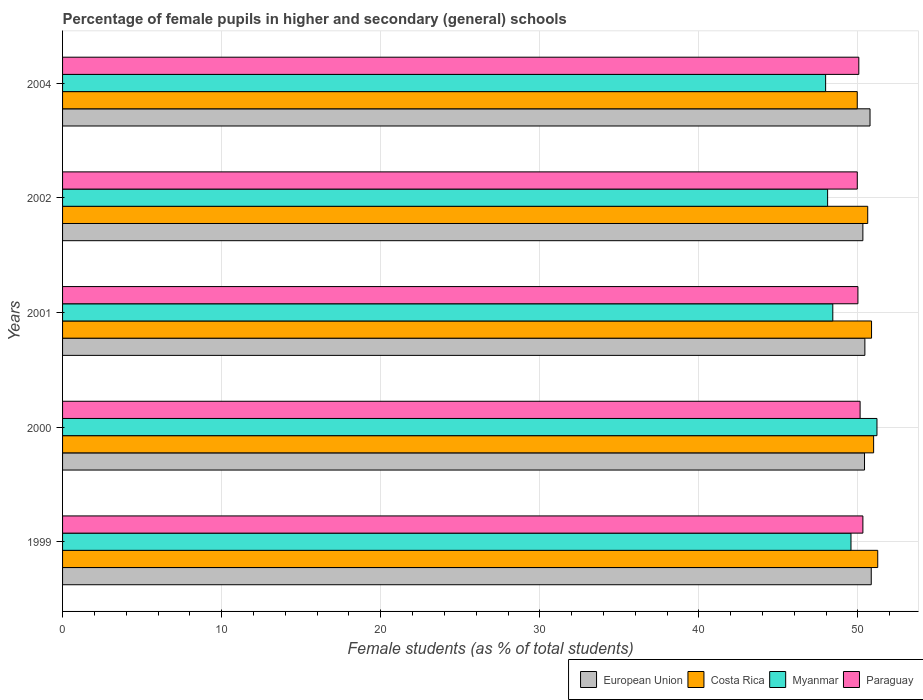How many different coloured bars are there?
Keep it short and to the point. 4. Are the number of bars on each tick of the Y-axis equal?
Offer a terse response. Yes. How many bars are there on the 2nd tick from the top?
Offer a very short reply. 4. How many bars are there on the 5th tick from the bottom?
Provide a succinct answer. 4. In how many cases, is the number of bars for a given year not equal to the number of legend labels?
Offer a very short reply. 0. What is the percentage of female pupils in higher and secondary schools in Myanmar in 1999?
Your answer should be very brief. 49.56. Across all years, what is the maximum percentage of female pupils in higher and secondary schools in Myanmar?
Make the answer very short. 51.19. Across all years, what is the minimum percentage of female pupils in higher and secondary schools in Paraguay?
Offer a terse response. 49.96. In which year was the percentage of female pupils in higher and secondary schools in European Union maximum?
Give a very brief answer. 1999. What is the total percentage of female pupils in higher and secondary schools in Costa Rica in the graph?
Give a very brief answer. 253.64. What is the difference between the percentage of female pupils in higher and secondary schools in European Union in 1999 and that in 2002?
Ensure brevity in your answer.  0.53. What is the difference between the percentage of female pupils in higher and secondary schools in Paraguay in 2004 and the percentage of female pupils in higher and secondary schools in European Union in 2001?
Ensure brevity in your answer.  -0.38. What is the average percentage of female pupils in higher and secondary schools in Myanmar per year?
Your response must be concise. 49.05. In the year 2004, what is the difference between the percentage of female pupils in higher and secondary schools in Myanmar and percentage of female pupils in higher and secondary schools in Paraguay?
Provide a short and direct response. -2.09. What is the ratio of the percentage of female pupils in higher and secondary schools in Myanmar in 1999 to that in 2002?
Your answer should be very brief. 1.03. Is the difference between the percentage of female pupils in higher and secondary schools in Myanmar in 1999 and 2004 greater than the difference between the percentage of female pupils in higher and secondary schools in Paraguay in 1999 and 2004?
Your response must be concise. Yes. What is the difference between the highest and the second highest percentage of female pupils in higher and secondary schools in European Union?
Give a very brief answer. 0.08. What is the difference between the highest and the lowest percentage of female pupils in higher and secondary schools in European Union?
Offer a very short reply. 0.53. In how many years, is the percentage of female pupils in higher and secondary schools in European Union greater than the average percentage of female pupils in higher and secondary schools in European Union taken over all years?
Make the answer very short. 2. Is the sum of the percentage of female pupils in higher and secondary schools in Paraguay in 1999 and 2001 greater than the maximum percentage of female pupils in higher and secondary schools in Myanmar across all years?
Offer a very short reply. Yes. Is it the case that in every year, the sum of the percentage of female pupils in higher and secondary schools in Paraguay and percentage of female pupils in higher and secondary schools in European Union is greater than the sum of percentage of female pupils in higher and secondary schools in Myanmar and percentage of female pupils in higher and secondary schools in Costa Rica?
Provide a short and direct response. No. What does the 2nd bar from the bottom in 2004 represents?
Give a very brief answer. Costa Rica. Is it the case that in every year, the sum of the percentage of female pupils in higher and secondary schools in Costa Rica and percentage of female pupils in higher and secondary schools in Myanmar is greater than the percentage of female pupils in higher and secondary schools in Paraguay?
Give a very brief answer. Yes. Are all the bars in the graph horizontal?
Your answer should be very brief. Yes. Does the graph contain grids?
Provide a short and direct response. Yes. Where does the legend appear in the graph?
Provide a succinct answer. Bottom right. How many legend labels are there?
Your answer should be compact. 4. How are the legend labels stacked?
Keep it short and to the point. Horizontal. What is the title of the graph?
Make the answer very short. Percentage of female pupils in higher and secondary (general) schools. What is the label or title of the X-axis?
Your answer should be compact. Female students (as % of total students). What is the Female students (as % of total students) of European Union in 1999?
Provide a short and direct response. 50.83. What is the Female students (as % of total students) of Costa Rica in 1999?
Provide a succinct answer. 51.24. What is the Female students (as % of total students) in Myanmar in 1999?
Your answer should be very brief. 49.56. What is the Female students (as % of total students) in Paraguay in 1999?
Provide a short and direct response. 50.31. What is the Female students (as % of total students) of European Union in 2000?
Your response must be concise. 50.41. What is the Female students (as % of total students) in Costa Rica in 2000?
Provide a short and direct response. 50.98. What is the Female students (as % of total students) of Myanmar in 2000?
Ensure brevity in your answer.  51.19. What is the Female students (as % of total students) in Paraguay in 2000?
Ensure brevity in your answer.  50.13. What is the Female students (as % of total students) of European Union in 2001?
Your answer should be compact. 50.43. What is the Female students (as % of total students) in Costa Rica in 2001?
Your response must be concise. 50.85. What is the Female students (as % of total students) in Myanmar in 2001?
Provide a succinct answer. 48.42. What is the Female students (as % of total students) in Paraguay in 2001?
Offer a very short reply. 50. What is the Female students (as % of total students) of European Union in 2002?
Give a very brief answer. 50.31. What is the Female students (as % of total students) of Costa Rica in 2002?
Provide a succinct answer. 50.61. What is the Female students (as % of total students) of Myanmar in 2002?
Offer a terse response. 48.09. What is the Female students (as % of total students) in Paraguay in 2002?
Provide a short and direct response. 49.96. What is the Female students (as % of total students) in European Union in 2004?
Your answer should be very brief. 50.76. What is the Female students (as % of total students) in Costa Rica in 2004?
Provide a succinct answer. 49.95. What is the Female students (as % of total students) in Myanmar in 2004?
Provide a succinct answer. 47.97. What is the Female students (as % of total students) in Paraguay in 2004?
Offer a terse response. 50.05. Across all years, what is the maximum Female students (as % of total students) in European Union?
Your response must be concise. 50.83. Across all years, what is the maximum Female students (as % of total students) of Costa Rica?
Offer a very short reply. 51.24. Across all years, what is the maximum Female students (as % of total students) of Myanmar?
Keep it short and to the point. 51.19. Across all years, what is the maximum Female students (as % of total students) of Paraguay?
Keep it short and to the point. 50.31. Across all years, what is the minimum Female students (as % of total students) in European Union?
Ensure brevity in your answer.  50.31. Across all years, what is the minimum Female students (as % of total students) of Costa Rica?
Provide a succinct answer. 49.95. Across all years, what is the minimum Female students (as % of total students) of Myanmar?
Give a very brief answer. 47.97. Across all years, what is the minimum Female students (as % of total students) of Paraguay?
Offer a very short reply. 49.96. What is the total Female students (as % of total students) of European Union in the graph?
Ensure brevity in your answer.  252.74. What is the total Female students (as % of total students) in Costa Rica in the graph?
Your response must be concise. 253.64. What is the total Female students (as % of total students) of Myanmar in the graph?
Make the answer very short. 245.23. What is the total Female students (as % of total students) in Paraguay in the graph?
Offer a very short reply. 250.44. What is the difference between the Female students (as % of total students) of European Union in 1999 and that in 2000?
Provide a succinct answer. 0.42. What is the difference between the Female students (as % of total students) in Costa Rica in 1999 and that in 2000?
Your response must be concise. 0.26. What is the difference between the Female students (as % of total students) in Myanmar in 1999 and that in 2000?
Give a very brief answer. -1.63. What is the difference between the Female students (as % of total students) of Paraguay in 1999 and that in 2000?
Your response must be concise. 0.17. What is the difference between the Female students (as % of total students) in European Union in 1999 and that in 2001?
Ensure brevity in your answer.  0.4. What is the difference between the Female students (as % of total students) in Costa Rica in 1999 and that in 2001?
Provide a short and direct response. 0.39. What is the difference between the Female students (as % of total students) of Myanmar in 1999 and that in 2001?
Keep it short and to the point. 1.14. What is the difference between the Female students (as % of total students) of Paraguay in 1999 and that in 2001?
Provide a succinct answer. 0.31. What is the difference between the Female students (as % of total students) in European Union in 1999 and that in 2002?
Make the answer very short. 0.53. What is the difference between the Female students (as % of total students) of Costa Rica in 1999 and that in 2002?
Ensure brevity in your answer.  0.63. What is the difference between the Female students (as % of total students) in Myanmar in 1999 and that in 2002?
Offer a terse response. 1.47. What is the difference between the Female students (as % of total students) of Paraguay in 1999 and that in 2002?
Your answer should be compact. 0.35. What is the difference between the Female students (as % of total students) in European Union in 1999 and that in 2004?
Keep it short and to the point. 0.08. What is the difference between the Female students (as % of total students) of Costa Rica in 1999 and that in 2004?
Offer a very short reply. 1.29. What is the difference between the Female students (as % of total students) in Myanmar in 1999 and that in 2004?
Your answer should be very brief. 1.59. What is the difference between the Female students (as % of total students) in Paraguay in 1999 and that in 2004?
Offer a very short reply. 0.26. What is the difference between the Female students (as % of total students) of European Union in 2000 and that in 2001?
Keep it short and to the point. -0.02. What is the difference between the Female students (as % of total students) of Costa Rica in 2000 and that in 2001?
Keep it short and to the point. 0.13. What is the difference between the Female students (as % of total students) in Myanmar in 2000 and that in 2001?
Offer a terse response. 2.78. What is the difference between the Female students (as % of total students) in Paraguay in 2000 and that in 2001?
Keep it short and to the point. 0.14. What is the difference between the Female students (as % of total students) in European Union in 2000 and that in 2002?
Ensure brevity in your answer.  0.1. What is the difference between the Female students (as % of total students) of Costa Rica in 2000 and that in 2002?
Offer a terse response. 0.37. What is the difference between the Female students (as % of total students) of Myanmar in 2000 and that in 2002?
Your answer should be compact. 3.1. What is the difference between the Female students (as % of total students) of Paraguay in 2000 and that in 2002?
Provide a succinct answer. 0.18. What is the difference between the Female students (as % of total students) of European Union in 2000 and that in 2004?
Make the answer very short. -0.35. What is the difference between the Female students (as % of total students) of Costa Rica in 2000 and that in 2004?
Give a very brief answer. 1.03. What is the difference between the Female students (as % of total students) of Myanmar in 2000 and that in 2004?
Your answer should be compact. 3.23. What is the difference between the Female students (as % of total students) of Paraguay in 2000 and that in 2004?
Keep it short and to the point. 0.08. What is the difference between the Female students (as % of total students) in European Union in 2001 and that in 2002?
Ensure brevity in your answer.  0.13. What is the difference between the Female students (as % of total students) in Costa Rica in 2001 and that in 2002?
Offer a very short reply. 0.24. What is the difference between the Female students (as % of total students) of Myanmar in 2001 and that in 2002?
Give a very brief answer. 0.33. What is the difference between the Female students (as % of total students) in Paraguay in 2001 and that in 2002?
Keep it short and to the point. 0.04. What is the difference between the Female students (as % of total students) in European Union in 2001 and that in 2004?
Your answer should be very brief. -0.32. What is the difference between the Female students (as % of total students) in Costa Rica in 2001 and that in 2004?
Offer a terse response. 0.9. What is the difference between the Female students (as % of total students) in Myanmar in 2001 and that in 2004?
Your response must be concise. 0.45. What is the difference between the Female students (as % of total students) of Paraguay in 2001 and that in 2004?
Offer a terse response. -0.06. What is the difference between the Female students (as % of total students) in European Union in 2002 and that in 2004?
Provide a succinct answer. -0.45. What is the difference between the Female students (as % of total students) of Costa Rica in 2002 and that in 2004?
Keep it short and to the point. 0.66. What is the difference between the Female students (as % of total students) in Myanmar in 2002 and that in 2004?
Your response must be concise. 0.12. What is the difference between the Female students (as % of total students) of Paraguay in 2002 and that in 2004?
Give a very brief answer. -0.1. What is the difference between the Female students (as % of total students) of European Union in 1999 and the Female students (as % of total students) of Costa Rica in 2000?
Provide a succinct answer. -0.15. What is the difference between the Female students (as % of total students) in European Union in 1999 and the Female students (as % of total students) in Myanmar in 2000?
Your answer should be very brief. -0.36. What is the difference between the Female students (as % of total students) of European Union in 1999 and the Female students (as % of total students) of Paraguay in 2000?
Ensure brevity in your answer.  0.7. What is the difference between the Female students (as % of total students) in Costa Rica in 1999 and the Female students (as % of total students) in Myanmar in 2000?
Offer a very short reply. 0.05. What is the difference between the Female students (as % of total students) of Costa Rica in 1999 and the Female students (as % of total students) of Paraguay in 2000?
Offer a very short reply. 1.11. What is the difference between the Female students (as % of total students) in Myanmar in 1999 and the Female students (as % of total students) in Paraguay in 2000?
Ensure brevity in your answer.  -0.57. What is the difference between the Female students (as % of total students) in European Union in 1999 and the Female students (as % of total students) in Costa Rica in 2001?
Your answer should be very brief. -0.02. What is the difference between the Female students (as % of total students) of European Union in 1999 and the Female students (as % of total students) of Myanmar in 2001?
Make the answer very short. 2.42. What is the difference between the Female students (as % of total students) of European Union in 1999 and the Female students (as % of total students) of Paraguay in 2001?
Give a very brief answer. 0.84. What is the difference between the Female students (as % of total students) in Costa Rica in 1999 and the Female students (as % of total students) in Myanmar in 2001?
Offer a very short reply. 2.82. What is the difference between the Female students (as % of total students) in Costa Rica in 1999 and the Female students (as % of total students) in Paraguay in 2001?
Your response must be concise. 1.25. What is the difference between the Female students (as % of total students) of Myanmar in 1999 and the Female students (as % of total students) of Paraguay in 2001?
Your response must be concise. -0.44. What is the difference between the Female students (as % of total students) of European Union in 1999 and the Female students (as % of total students) of Costa Rica in 2002?
Your answer should be compact. 0.22. What is the difference between the Female students (as % of total students) in European Union in 1999 and the Female students (as % of total students) in Myanmar in 2002?
Provide a succinct answer. 2.74. What is the difference between the Female students (as % of total students) of European Union in 1999 and the Female students (as % of total students) of Paraguay in 2002?
Your answer should be very brief. 0.88. What is the difference between the Female students (as % of total students) of Costa Rica in 1999 and the Female students (as % of total students) of Myanmar in 2002?
Your answer should be very brief. 3.15. What is the difference between the Female students (as % of total students) in Costa Rica in 1999 and the Female students (as % of total students) in Paraguay in 2002?
Give a very brief answer. 1.29. What is the difference between the Female students (as % of total students) of Myanmar in 1999 and the Female students (as % of total students) of Paraguay in 2002?
Make the answer very short. -0.4. What is the difference between the Female students (as % of total students) in European Union in 1999 and the Female students (as % of total students) in Costa Rica in 2004?
Offer a very short reply. 0.88. What is the difference between the Female students (as % of total students) in European Union in 1999 and the Female students (as % of total students) in Myanmar in 2004?
Provide a short and direct response. 2.87. What is the difference between the Female students (as % of total students) in European Union in 1999 and the Female students (as % of total students) in Paraguay in 2004?
Provide a short and direct response. 0.78. What is the difference between the Female students (as % of total students) of Costa Rica in 1999 and the Female students (as % of total students) of Myanmar in 2004?
Make the answer very short. 3.28. What is the difference between the Female students (as % of total students) of Costa Rica in 1999 and the Female students (as % of total students) of Paraguay in 2004?
Provide a succinct answer. 1.19. What is the difference between the Female students (as % of total students) in Myanmar in 1999 and the Female students (as % of total students) in Paraguay in 2004?
Make the answer very short. -0.49. What is the difference between the Female students (as % of total students) in European Union in 2000 and the Female students (as % of total students) in Costa Rica in 2001?
Provide a succinct answer. -0.44. What is the difference between the Female students (as % of total students) of European Union in 2000 and the Female students (as % of total students) of Myanmar in 2001?
Your response must be concise. 1.99. What is the difference between the Female students (as % of total students) in European Union in 2000 and the Female students (as % of total students) in Paraguay in 2001?
Keep it short and to the point. 0.41. What is the difference between the Female students (as % of total students) of Costa Rica in 2000 and the Female students (as % of total students) of Myanmar in 2001?
Your answer should be very brief. 2.57. What is the difference between the Female students (as % of total students) of Costa Rica in 2000 and the Female students (as % of total students) of Paraguay in 2001?
Your answer should be compact. 0.99. What is the difference between the Female students (as % of total students) in Myanmar in 2000 and the Female students (as % of total students) in Paraguay in 2001?
Ensure brevity in your answer.  1.2. What is the difference between the Female students (as % of total students) of European Union in 2000 and the Female students (as % of total students) of Costa Rica in 2002?
Ensure brevity in your answer.  -0.2. What is the difference between the Female students (as % of total students) of European Union in 2000 and the Female students (as % of total students) of Myanmar in 2002?
Provide a short and direct response. 2.32. What is the difference between the Female students (as % of total students) in European Union in 2000 and the Female students (as % of total students) in Paraguay in 2002?
Your response must be concise. 0.45. What is the difference between the Female students (as % of total students) in Costa Rica in 2000 and the Female students (as % of total students) in Myanmar in 2002?
Provide a succinct answer. 2.89. What is the difference between the Female students (as % of total students) in Costa Rica in 2000 and the Female students (as % of total students) in Paraguay in 2002?
Provide a succinct answer. 1.03. What is the difference between the Female students (as % of total students) in Myanmar in 2000 and the Female students (as % of total students) in Paraguay in 2002?
Offer a terse response. 1.24. What is the difference between the Female students (as % of total students) in European Union in 2000 and the Female students (as % of total students) in Costa Rica in 2004?
Ensure brevity in your answer.  0.46. What is the difference between the Female students (as % of total students) of European Union in 2000 and the Female students (as % of total students) of Myanmar in 2004?
Your answer should be very brief. 2.44. What is the difference between the Female students (as % of total students) of European Union in 2000 and the Female students (as % of total students) of Paraguay in 2004?
Your answer should be compact. 0.36. What is the difference between the Female students (as % of total students) of Costa Rica in 2000 and the Female students (as % of total students) of Myanmar in 2004?
Ensure brevity in your answer.  3.02. What is the difference between the Female students (as % of total students) in Costa Rica in 2000 and the Female students (as % of total students) in Paraguay in 2004?
Provide a short and direct response. 0.93. What is the difference between the Female students (as % of total students) of Myanmar in 2000 and the Female students (as % of total students) of Paraguay in 2004?
Make the answer very short. 1.14. What is the difference between the Female students (as % of total students) in European Union in 2001 and the Female students (as % of total students) in Costa Rica in 2002?
Offer a very short reply. -0.18. What is the difference between the Female students (as % of total students) of European Union in 2001 and the Female students (as % of total students) of Myanmar in 2002?
Your answer should be compact. 2.34. What is the difference between the Female students (as % of total students) in European Union in 2001 and the Female students (as % of total students) in Paraguay in 2002?
Ensure brevity in your answer.  0.48. What is the difference between the Female students (as % of total students) in Costa Rica in 2001 and the Female students (as % of total students) in Myanmar in 2002?
Provide a succinct answer. 2.76. What is the difference between the Female students (as % of total students) of Costa Rica in 2001 and the Female students (as % of total students) of Paraguay in 2002?
Provide a short and direct response. 0.9. What is the difference between the Female students (as % of total students) of Myanmar in 2001 and the Female students (as % of total students) of Paraguay in 2002?
Your answer should be very brief. -1.54. What is the difference between the Female students (as % of total students) in European Union in 2001 and the Female students (as % of total students) in Costa Rica in 2004?
Give a very brief answer. 0.48. What is the difference between the Female students (as % of total students) of European Union in 2001 and the Female students (as % of total students) of Myanmar in 2004?
Your answer should be very brief. 2.47. What is the difference between the Female students (as % of total students) in European Union in 2001 and the Female students (as % of total students) in Paraguay in 2004?
Give a very brief answer. 0.38. What is the difference between the Female students (as % of total students) of Costa Rica in 2001 and the Female students (as % of total students) of Myanmar in 2004?
Provide a succinct answer. 2.89. What is the difference between the Female students (as % of total students) of Costa Rica in 2001 and the Female students (as % of total students) of Paraguay in 2004?
Offer a terse response. 0.8. What is the difference between the Female students (as % of total students) in Myanmar in 2001 and the Female students (as % of total students) in Paraguay in 2004?
Give a very brief answer. -1.64. What is the difference between the Female students (as % of total students) of European Union in 2002 and the Female students (as % of total students) of Costa Rica in 2004?
Your answer should be compact. 0.35. What is the difference between the Female students (as % of total students) of European Union in 2002 and the Female students (as % of total students) of Myanmar in 2004?
Offer a terse response. 2.34. What is the difference between the Female students (as % of total students) in European Union in 2002 and the Female students (as % of total students) in Paraguay in 2004?
Your response must be concise. 0.26. What is the difference between the Female students (as % of total students) of Costa Rica in 2002 and the Female students (as % of total students) of Myanmar in 2004?
Offer a very short reply. 2.65. What is the difference between the Female students (as % of total students) in Costa Rica in 2002 and the Female students (as % of total students) in Paraguay in 2004?
Make the answer very short. 0.56. What is the difference between the Female students (as % of total students) of Myanmar in 2002 and the Female students (as % of total students) of Paraguay in 2004?
Ensure brevity in your answer.  -1.96. What is the average Female students (as % of total students) in European Union per year?
Make the answer very short. 50.55. What is the average Female students (as % of total students) of Costa Rica per year?
Give a very brief answer. 50.73. What is the average Female students (as % of total students) of Myanmar per year?
Keep it short and to the point. 49.05. What is the average Female students (as % of total students) of Paraguay per year?
Provide a short and direct response. 50.09. In the year 1999, what is the difference between the Female students (as % of total students) of European Union and Female students (as % of total students) of Costa Rica?
Provide a short and direct response. -0.41. In the year 1999, what is the difference between the Female students (as % of total students) of European Union and Female students (as % of total students) of Myanmar?
Your answer should be compact. 1.27. In the year 1999, what is the difference between the Female students (as % of total students) in European Union and Female students (as % of total students) in Paraguay?
Your answer should be very brief. 0.53. In the year 1999, what is the difference between the Female students (as % of total students) of Costa Rica and Female students (as % of total students) of Myanmar?
Your response must be concise. 1.68. In the year 1999, what is the difference between the Female students (as % of total students) of Costa Rica and Female students (as % of total students) of Paraguay?
Your answer should be very brief. 0.93. In the year 1999, what is the difference between the Female students (as % of total students) of Myanmar and Female students (as % of total students) of Paraguay?
Ensure brevity in your answer.  -0.75. In the year 2000, what is the difference between the Female students (as % of total students) in European Union and Female students (as % of total students) in Costa Rica?
Keep it short and to the point. -0.57. In the year 2000, what is the difference between the Female students (as % of total students) in European Union and Female students (as % of total students) in Myanmar?
Provide a succinct answer. -0.78. In the year 2000, what is the difference between the Female students (as % of total students) of European Union and Female students (as % of total students) of Paraguay?
Provide a short and direct response. 0.28. In the year 2000, what is the difference between the Female students (as % of total students) of Costa Rica and Female students (as % of total students) of Myanmar?
Your answer should be compact. -0.21. In the year 2000, what is the difference between the Female students (as % of total students) in Costa Rica and Female students (as % of total students) in Paraguay?
Provide a succinct answer. 0.85. In the year 2000, what is the difference between the Female students (as % of total students) of Myanmar and Female students (as % of total students) of Paraguay?
Your answer should be very brief. 1.06. In the year 2001, what is the difference between the Female students (as % of total students) of European Union and Female students (as % of total students) of Costa Rica?
Provide a succinct answer. -0.42. In the year 2001, what is the difference between the Female students (as % of total students) of European Union and Female students (as % of total students) of Myanmar?
Your answer should be very brief. 2.02. In the year 2001, what is the difference between the Female students (as % of total students) of European Union and Female students (as % of total students) of Paraguay?
Your answer should be compact. 0.44. In the year 2001, what is the difference between the Female students (as % of total students) in Costa Rica and Female students (as % of total students) in Myanmar?
Provide a short and direct response. 2.44. In the year 2001, what is the difference between the Female students (as % of total students) in Costa Rica and Female students (as % of total students) in Paraguay?
Your response must be concise. 0.86. In the year 2001, what is the difference between the Female students (as % of total students) of Myanmar and Female students (as % of total students) of Paraguay?
Provide a succinct answer. -1.58. In the year 2002, what is the difference between the Female students (as % of total students) of European Union and Female students (as % of total students) of Costa Rica?
Ensure brevity in your answer.  -0.3. In the year 2002, what is the difference between the Female students (as % of total students) in European Union and Female students (as % of total students) in Myanmar?
Make the answer very short. 2.22. In the year 2002, what is the difference between the Female students (as % of total students) of European Union and Female students (as % of total students) of Paraguay?
Provide a short and direct response. 0.35. In the year 2002, what is the difference between the Female students (as % of total students) of Costa Rica and Female students (as % of total students) of Myanmar?
Your answer should be very brief. 2.52. In the year 2002, what is the difference between the Female students (as % of total students) of Costa Rica and Female students (as % of total students) of Paraguay?
Your answer should be compact. 0.66. In the year 2002, what is the difference between the Female students (as % of total students) of Myanmar and Female students (as % of total students) of Paraguay?
Keep it short and to the point. -1.87. In the year 2004, what is the difference between the Female students (as % of total students) of European Union and Female students (as % of total students) of Costa Rica?
Your response must be concise. 0.8. In the year 2004, what is the difference between the Female students (as % of total students) in European Union and Female students (as % of total students) in Myanmar?
Keep it short and to the point. 2.79. In the year 2004, what is the difference between the Female students (as % of total students) in European Union and Female students (as % of total students) in Paraguay?
Offer a terse response. 0.7. In the year 2004, what is the difference between the Female students (as % of total students) of Costa Rica and Female students (as % of total students) of Myanmar?
Give a very brief answer. 1.99. In the year 2004, what is the difference between the Female students (as % of total students) of Costa Rica and Female students (as % of total students) of Paraguay?
Your answer should be compact. -0.1. In the year 2004, what is the difference between the Female students (as % of total students) of Myanmar and Female students (as % of total students) of Paraguay?
Provide a short and direct response. -2.09. What is the ratio of the Female students (as % of total students) in European Union in 1999 to that in 2000?
Provide a short and direct response. 1.01. What is the ratio of the Female students (as % of total students) in Costa Rica in 1999 to that in 2000?
Make the answer very short. 1.01. What is the ratio of the Female students (as % of total students) in Myanmar in 1999 to that in 2000?
Give a very brief answer. 0.97. What is the ratio of the Female students (as % of total students) of European Union in 1999 to that in 2001?
Make the answer very short. 1.01. What is the ratio of the Female students (as % of total students) of Costa Rica in 1999 to that in 2001?
Make the answer very short. 1.01. What is the ratio of the Female students (as % of total students) of Myanmar in 1999 to that in 2001?
Make the answer very short. 1.02. What is the ratio of the Female students (as % of total students) of Paraguay in 1999 to that in 2001?
Provide a succinct answer. 1.01. What is the ratio of the Female students (as % of total students) of European Union in 1999 to that in 2002?
Your answer should be very brief. 1.01. What is the ratio of the Female students (as % of total students) in Costa Rica in 1999 to that in 2002?
Your answer should be compact. 1.01. What is the ratio of the Female students (as % of total students) of Myanmar in 1999 to that in 2002?
Your answer should be very brief. 1.03. What is the ratio of the Female students (as % of total students) of Paraguay in 1999 to that in 2002?
Offer a terse response. 1.01. What is the ratio of the Female students (as % of total students) in Costa Rica in 1999 to that in 2004?
Keep it short and to the point. 1.03. What is the ratio of the Female students (as % of total students) in Myanmar in 1999 to that in 2004?
Offer a terse response. 1.03. What is the ratio of the Female students (as % of total students) in Costa Rica in 2000 to that in 2001?
Offer a terse response. 1. What is the ratio of the Female students (as % of total students) in Myanmar in 2000 to that in 2001?
Provide a short and direct response. 1.06. What is the ratio of the Female students (as % of total students) of Paraguay in 2000 to that in 2001?
Provide a succinct answer. 1. What is the ratio of the Female students (as % of total students) of Costa Rica in 2000 to that in 2002?
Provide a succinct answer. 1.01. What is the ratio of the Female students (as % of total students) in Myanmar in 2000 to that in 2002?
Make the answer very short. 1.06. What is the ratio of the Female students (as % of total students) of Costa Rica in 2000 to that in 2004?
Offer a terse response. 1.02. What is the ratio of the Female students (as % of total students) in Myanmar in 2000 to that in 2004?
Your answer should be compact. 1.07. What is the ratio of the Female students (as % of total students) in European Union in 2001 to that in 2002?
Offer a very short reply. 1. What is the ratio of the Female students (as % of total students) in Costa Rica in 2001 to that in 2002?
Provide a succinct answer. 1. What is the ratio of the Female students (as % of total students) in Myanmar in 2001 to that in 2002?
Your response must be concise. 1.01. What is the ratio of the Female students (as % of total students) in Paraguay in 2001 to that in 2002?
Your answer should be very brief. 1. What is the ratio of the Female students (as % of total students) of Myanmar in 2001 to that in 2004?
Ensure brevity in your answer.  1.01. What is the ratio of the Female students (as % of total students) in Costa Rica in 2002 to that in 2004?
Provide a succinct answer. 1.01. What is the ratio of the Female students (as % of total students) of Paraguay in 2002 to that in 2004?
Give a very brief answer. 1. What is the difference between the highest and the second highest Female students (as % of total students) of European Union?
Keep it short and to the point. 0.08. What is the difference between the highest and the second highest Female students (as % of total students) in Costa Rica?
Offer a terse response. 0.26. What is the difference between the highest and the second highest Female students (as % of total students) in Myanmar?
Give a very brief answer. 1.63. What is the difference between the highest and the second highest Female students (as % of total students) in Paraguay?
Give a very brief answer. 0.17. What is the difference between the highest and the lowest Female students (as % of total students) in European Union?
Your answer should be very brief. 0.53. What is the difference between the highest and the lowest Female students (as % of total students) in Costa Rica?
Offer a very short reply. 1.29. What is the difference between the highest and the lowest Female students (as % of total students) of Myanmar?
Your response must be concise. 3.23. What is the difference between the highest and the lowest Female students (as % of total students) of Paraguay?
Offer a very short reply. 0.35. 